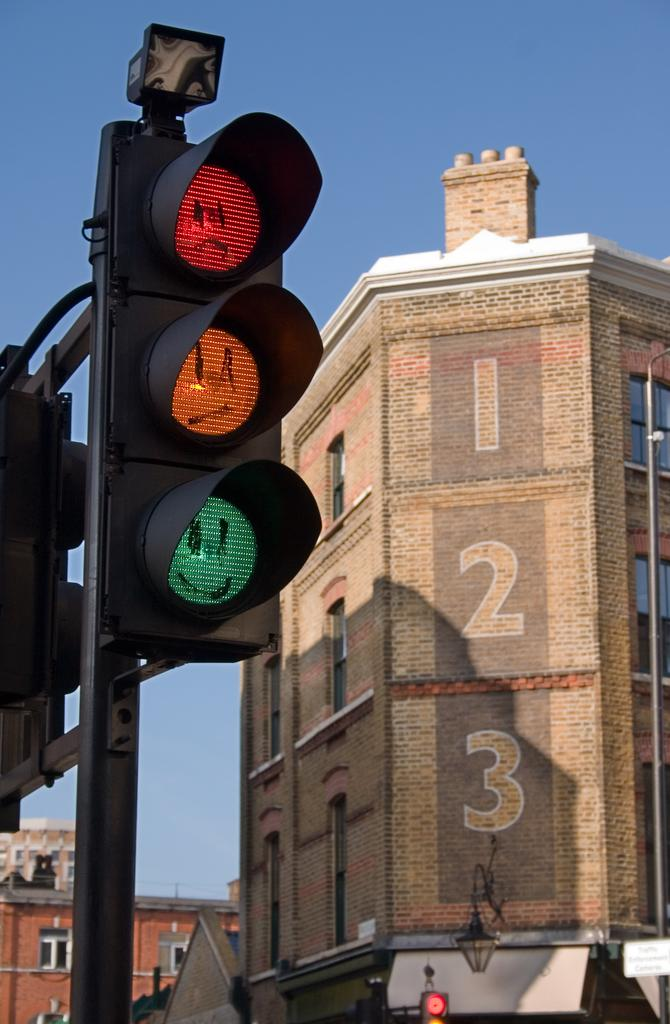<image>
Render a clear and concise summary of the photo. A brick building has the number 1, 2, 3 going down the corner of the wall. 